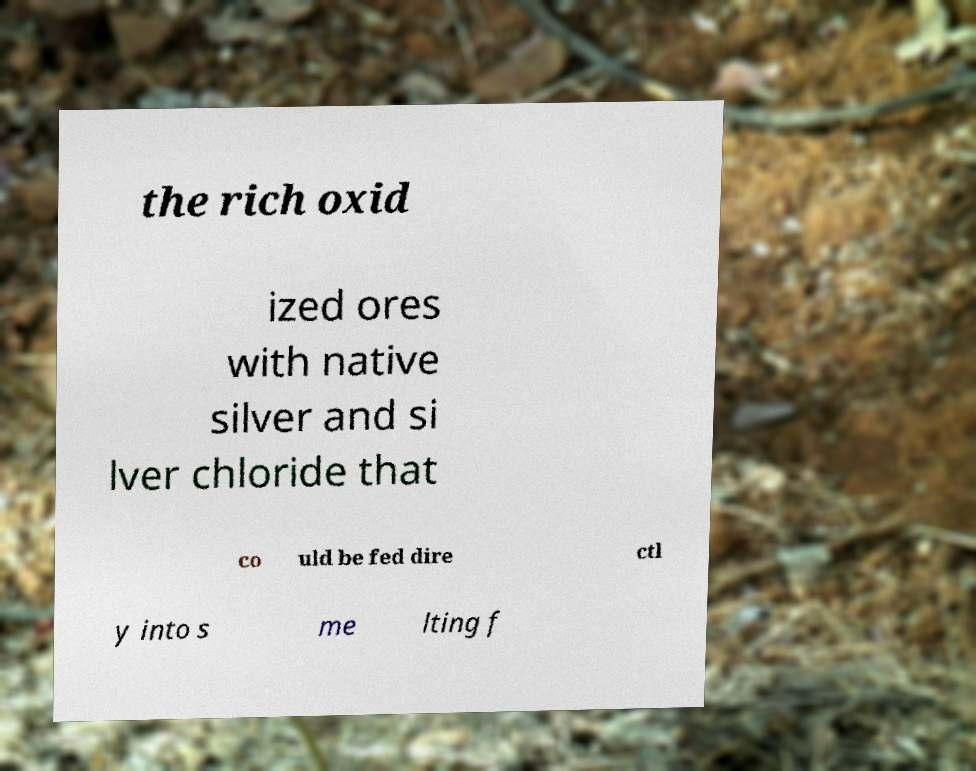There's text embedded in this image that I need extracted. Can you transcribe it verbatim? the rich oxid ized ores with native silver and si lver chloride that co uld be fed dire ctl y into s me lting f 